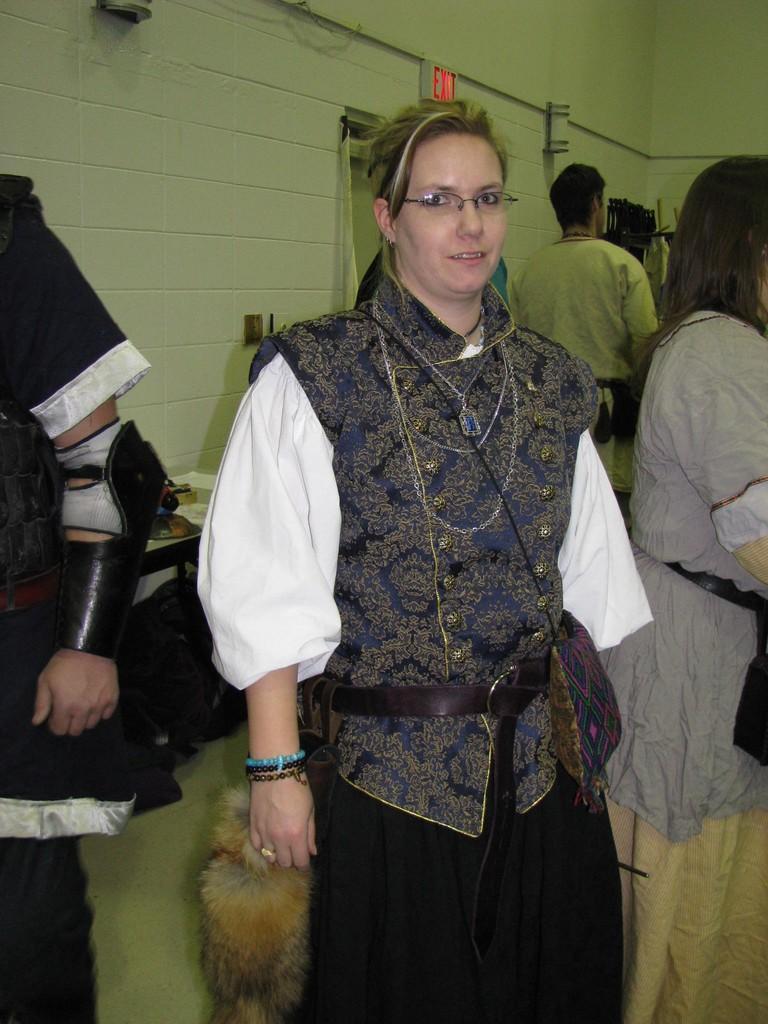Please provide a concise description of this image. In this image there is a woman in the middle who is wearing the costume. In the background there is a wall. There are few people standing beside her. At the top there is an exit board. In the background there is a table on which there is an idol. 